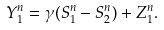Convert formula to latex. <formula><loc_0><loc_0><loc_500><loc_500>Y _ { 1 } ^ { n } = \gamma ( S _ { 1 } ^ { n } - S _ { 2 } ^ { n } ) + Z _ { 1 } ^ { n } .</formula> 